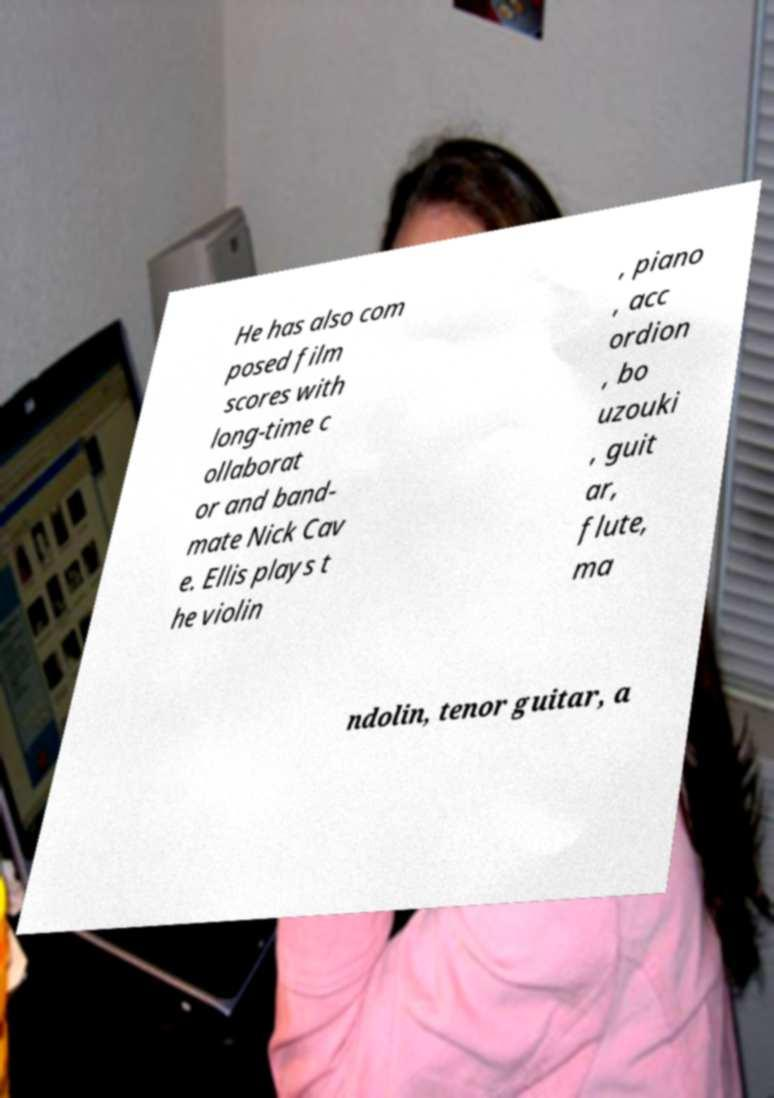What messages or text are displayed in this image? I need them in a readable, typed format. He has also com posed film scores with long-time c ollaborat or and band- mate Nick Cav e. Ellis plays t he violin , piano , acc ordion , bo uzouki , guit ar, flute, ma ndolin, tenor guitar, a 